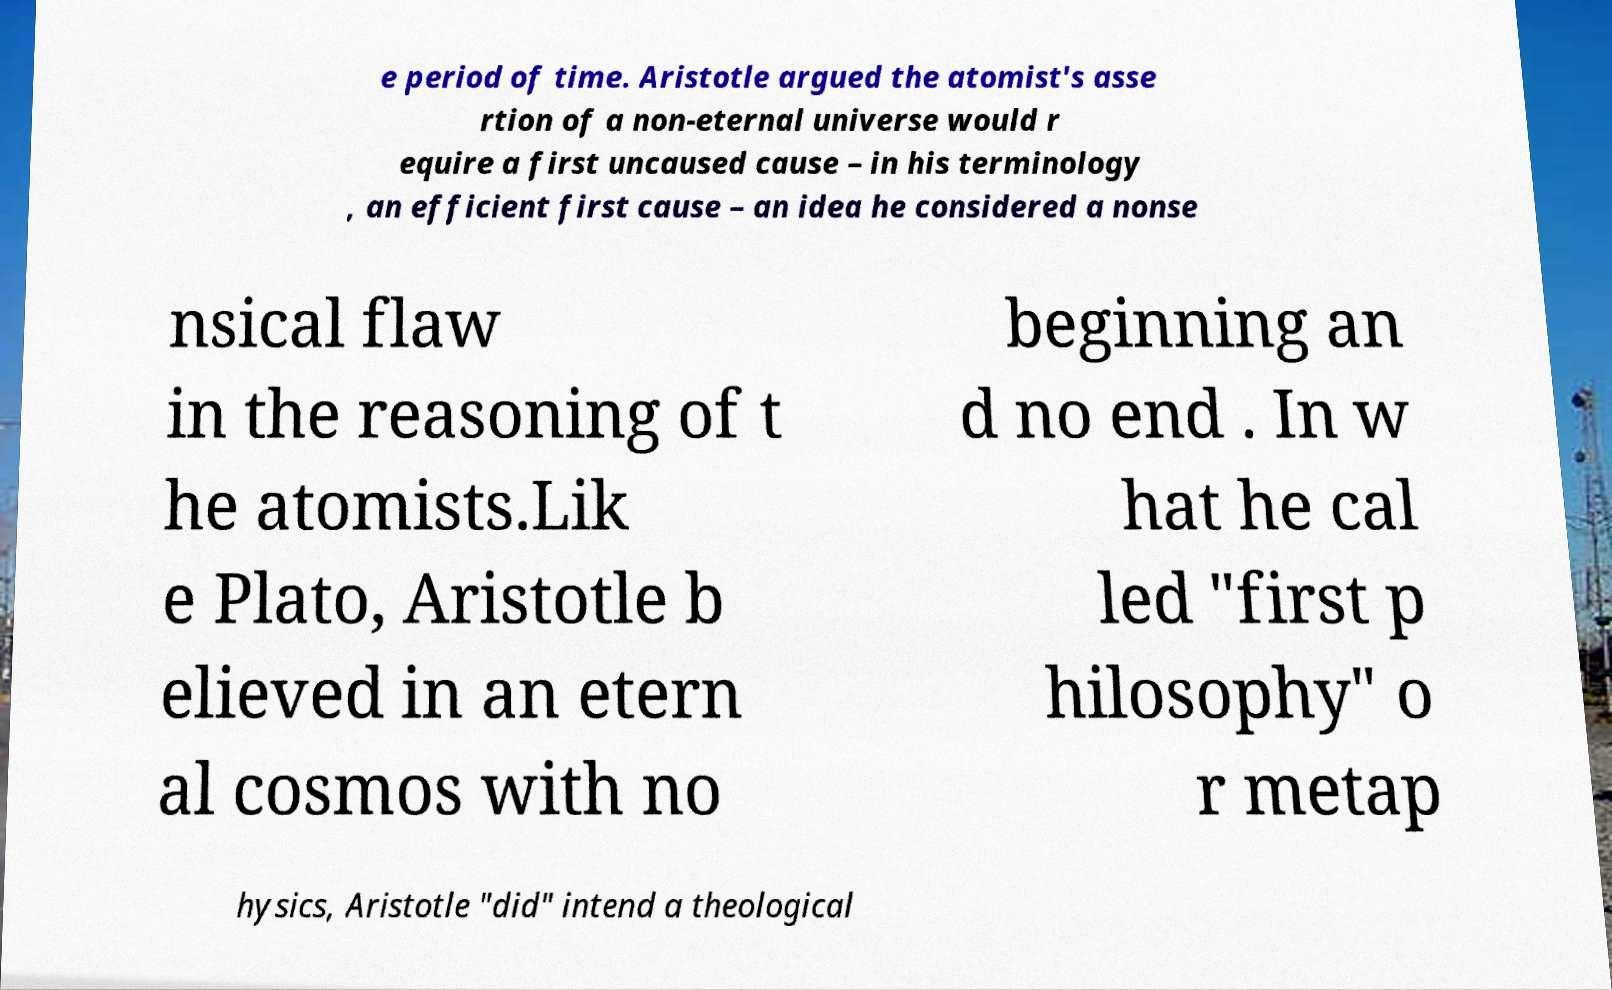There's text embedded in this image that I need extracted. Can you transcribe it verbatim? e period of time. Aristotle argued the atomist's asse rtion of a non-eternal universe would r equire a first uncaused cause – in his terminology , an efficient first cause – an idea he considered a nonse nsical flaw in the reasoning of t he atomists.Lik e Plato, Aristotle b elieved in an etern al cosmos with no beginning an d no end . In w hat he cal led "first p hilosophy" o r metap hysics, Aristotle "did" intend a theological 